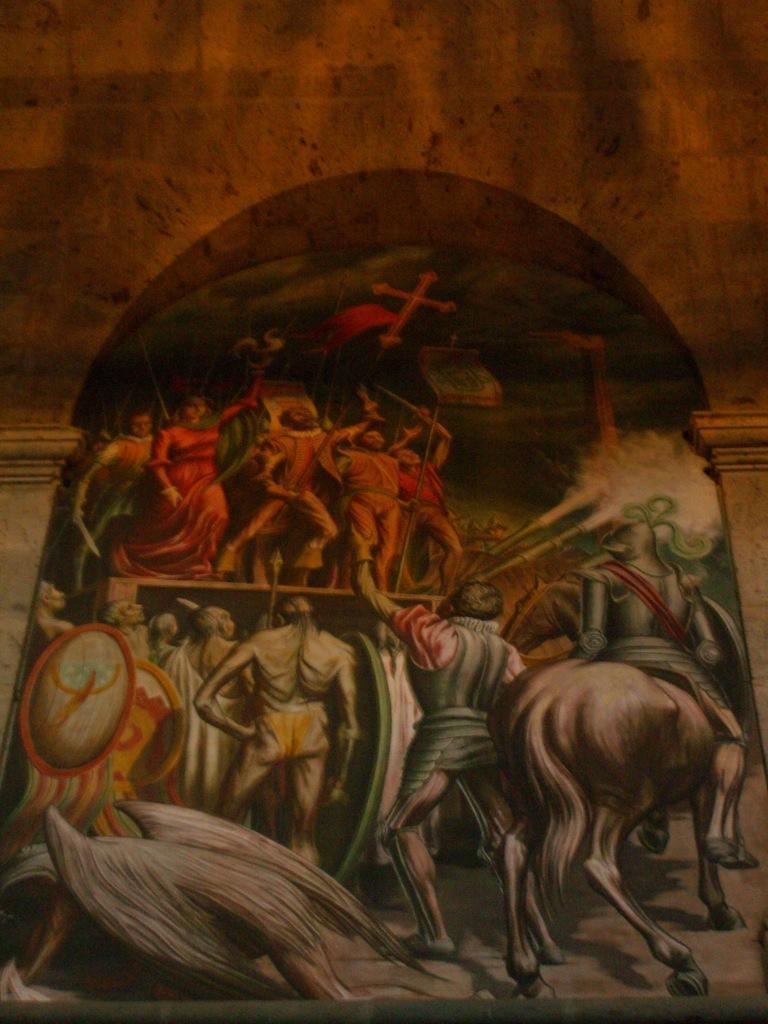Describe this image in one or two sentences. Here we can see a painting of persons and an animal. In the background we can see wall and pillars. 